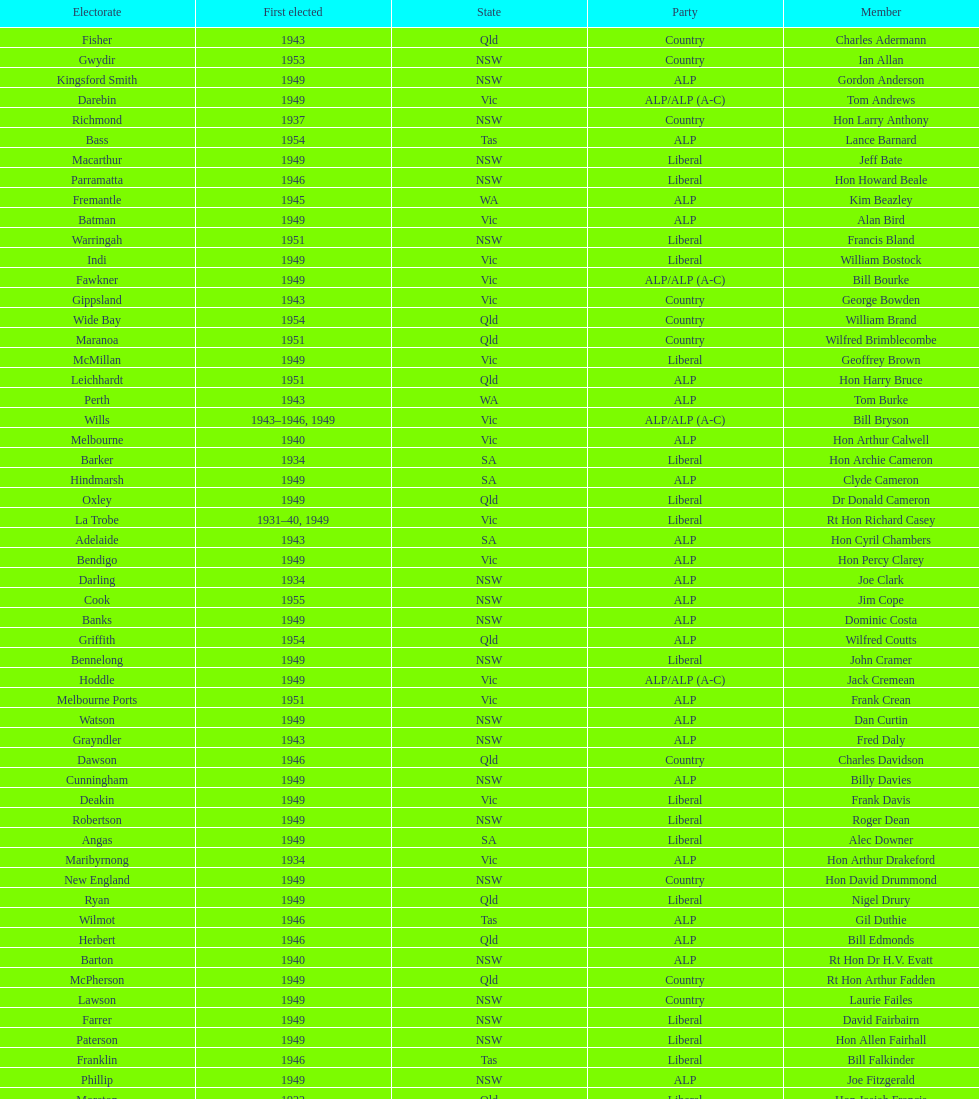When was joe clark first elected? 1934. 